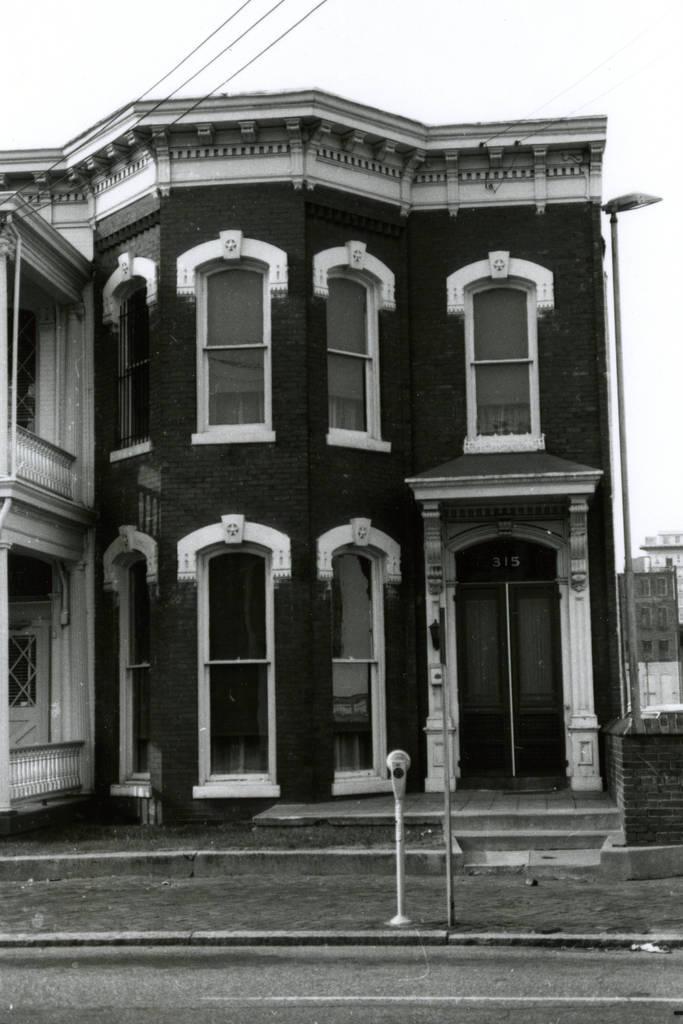Please provide a concise description of this image. It is a black and white image. In this image we can see the buildings, poles, wall, stairs, path and also the road. We can also see the light pole and also the wires. Sky is also visible in this image. 